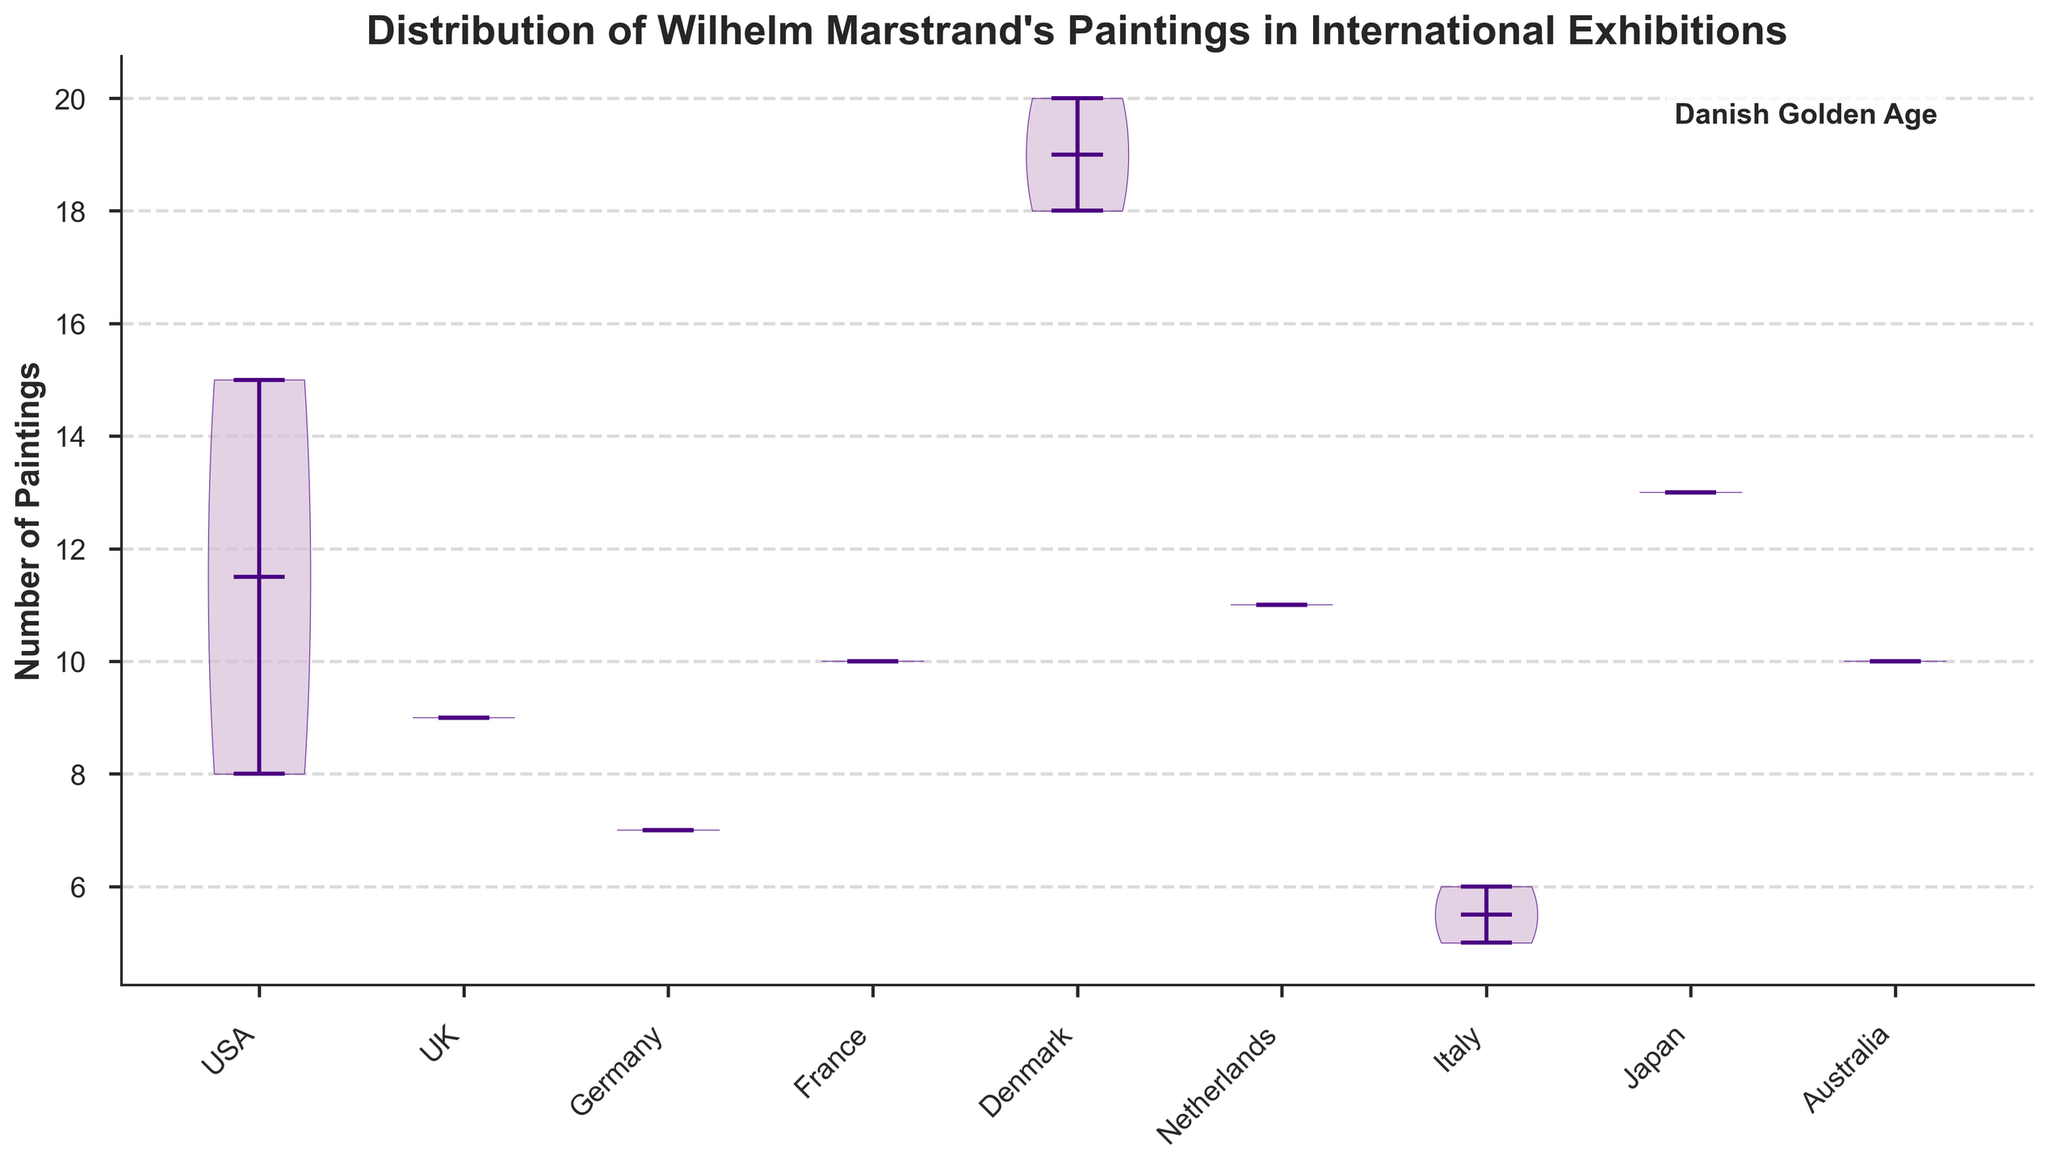What is the title of the chart? The title of the chart is located at the top and provides a general description of the data presented. Read the bolded text at the top of the figure to find the title.
Answer: Distribution of Wilhelm Marstrand's Paintings in International Exhibitions Which country has the widest distribution of exhibitions? To determine the country with the widest distribution, identify the country whose violin plot has the largest horizontal spread. This indicates more variability in the number of paintings.
Answer: Denmark What is the median number of Marstrand's paintings displayed in Germany? The median is represented by the horizontal line inside each violin plot. Locate the horizontal line within the Germany violin plot and read the corresponding value on the y-axis.
Answer: 7 Which country exhibited the highest number of Marstrand's paintings, and what is that number? The highest number of paintings is shown by the top end of the violin plot for each country. Identify the highest point across all violin plots.
Answer: Denmark, 20 What are the lower and upper limits of the violin plot for Marstrand's works in Italy? The lower and upper limits can be identified at the bottom and top ends of Italy's violin plot.
Answer: 5 and 6 Which countries displayed Marstrand's paintings with a median above 10? The median is indicated by the horizontal line in each violin plot. Compare them to the 10-mark on the y-axis.
Answer: USA, Denmark, Japan What's the range of paintings displayed in the UK? The range is the difference between the highest and lowest values of the violin plot for the UK. Identify the top and bottom ends of the UK violin plot and calculate the difference.
Answer: 9 How many paintings were displayed in the USA at the New York Metropolitan Museum of Art in 2019? Locate the data point corresponding to the USA from the given data and identify the number of paintings for the specific exhibition year and museum.
Answer: 15 What can you infer about the consistency of Marstrand's exhibition sizes in Japan compared to Germany? The consistency can be inferred by looking at the spread of the violin plots. A narrower violin plot suggests more consistency. Compare the spreads of Japan's and Germany's violin plots.
Answer: Japan is less consistent What is the sum of the number of Marstrand's paintings displayed in Italy? Sum the number of paintings from both data points in Italy from the given dataset.
Answer: 11 